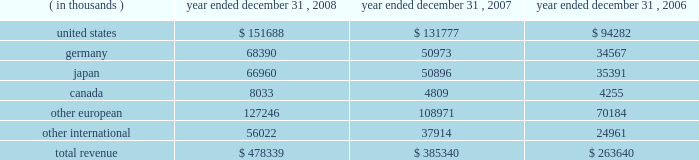15 .
Leases in january 1996 , the company entered into a lease agreement with an unrelated third party for a new corporate office facility , which the company occupied in february 1997 .
In may 2004 , the company entered into the first amendment to this lease agreement , effective january 1 , 2004 .
The lease was extended from an original period of 10 years , with an option for five additional years , to a period of 18 years from the inception date , with an option for five additional years .
The company incurred lease rental expense related to this facility of $ 1.3 million in 2008 , 2007 and 2006 .
The future minimum lease payments are $ 1.4 million per annum from january 1 , 2009 to december 31 , 2014 .
The future minimum lease payments from january 1 , 2015 through december 31 , 2019 will be determined based on prevailing market rental rates at the time of the extension , if elected .
The amended lease also provided for the lessor to reimburse the company for up to $ 550000 in building refurbishments completed through march 31 , 2006 .
These amounts have been recorded as a reduction of lease expense over the remaining term of the lease .
The company has also entered into various noncancellable operating leases for equipment and office space .
Office space lease expense totaled $ 9.3 million , $ 6.3 million and $ 4.7 million for the years ended december 31 , 2008 , 2007 and 2006 , respectively .
Future minimum lease payments under noncancellable operating leases for office space in effect at december 31 , 2008 are $ 8.8 million in 2009 , $ 6.6 million in 2010 , $ 3.0 million in 2011 , $ 1.8 million in 2012 and $ 1.1 million in 2013 .
16 .
Royalty agreements the company has entered into various renewable , nonexclusive license agreements under which the company has been granted access to the licensor 2019s technology and the right to sell the technology in the company 2019s product line .
Royalties are payable to developers of the software at various rates and amounts , which generally are based upon unit sales or revenue .
Royalty fees are reported in cost of goods sold and were $ 6.3 million , $ 5.2 million and $ 3.9 million for the years ended december 31 , 2008 , 2007 and 2006 , respectively .
17 .
Geographic information revenue to external customers is attributed to individual countries based upon the location of the customer .
Revenue by geographic area is as follows: .

In 2008 what was the percent of the revenue by geographic from the unite states? 
Computations: (151688 / 478339)
Answer: 0.31711. 